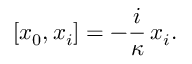Convert formula to latex. <formula><loc_0><loc_0><loc_500><loc_500>[ x _ { 0 } , x _ { i } ] = - \frac { i } \kappa \, x _ { i } .</formula> 